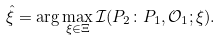Convert formula to latex. <formula><loc_0><loc_0><loc_500><loc_500>\hat { \xi } = \arg \max _ { \xi \in \Xi } \mathcal { I } ( P _ { 2 } \colon P _ { 1 } , \mathcal { O } _ { 1 } ; \xi ) .</formula> 